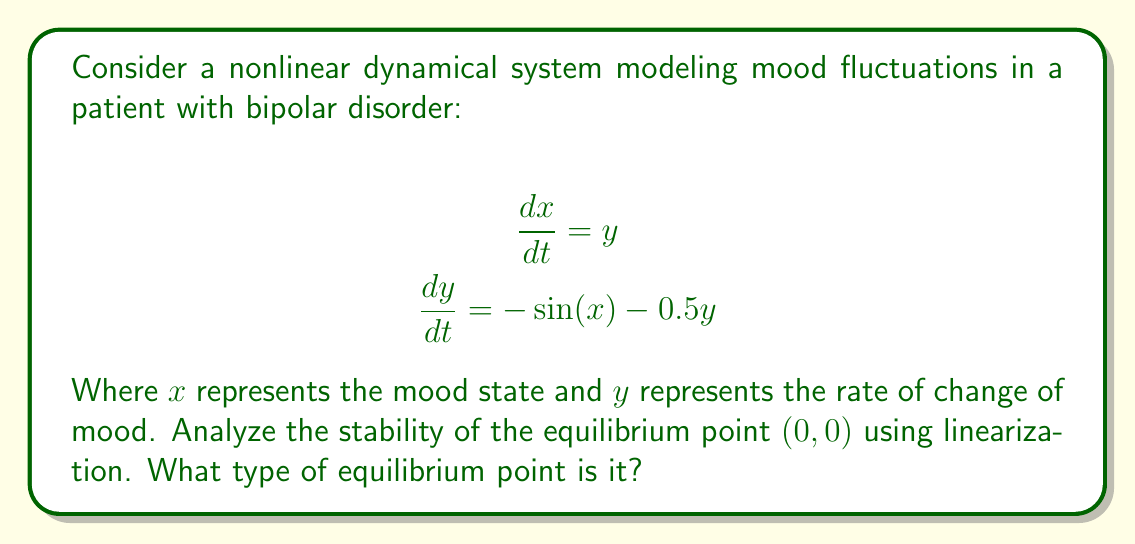Can you answer this question? 1) First, we need to find the Jacobian matrix of the system at the equilibrium point $(0,0)$:

   $$J = \begin{bmatrix}
   \frac{\partial f_1}{\partial x} & \frac{\partial f_1}{\partial y} \\
   \frac{\partial f_2}{\partial x} & \frac{\partial f_2}{\partial y}
   \end{bmatrix} = \begin{bmatrix}
   0 & 1 \\
   -\cos(x) & -0.5
   \end{bmatrix}$$

2) Evaluate the Jacobian at the equilibrium point $(0,0)$:

   $$J_{(0,0)} = \begin{bmatrix}
   0 & 1 \\
   -1 & -0.5
   \end{bmatrix}$$

3) Calculate the eigenvalues of $J_{(0,0)}$:

   $$\det(J_{(0,0)} - \lambda I) = \begin{vmatrix}
   -\lambda & 1 \\
   -1 & -0.5-\lambda
   \end{vmatrix} = \lambda^2 + 0.5\lambda + 1 = 0$$

4) Solve the characteristic equation:

   $$\lambda = \frac{-0.5 \pm \sqrt{0.25 - 4}}{2} = \frac{-0.5 \pm \sqrt{-3.75}}{2} = -0.25 \pm 0.968i$$

5) Analyze the eigenvalues:
   - The real part is negative (-0.25)
   - The imaginary part is non-zero

6) Conclusion: The equilibrium point $(0,0)$ is a stable spiral point. This indicates that the mood state will oscillate around the equilibrium with decreasing amplitude over time, eventually stabilizing.
Answer: Stable spiral point 